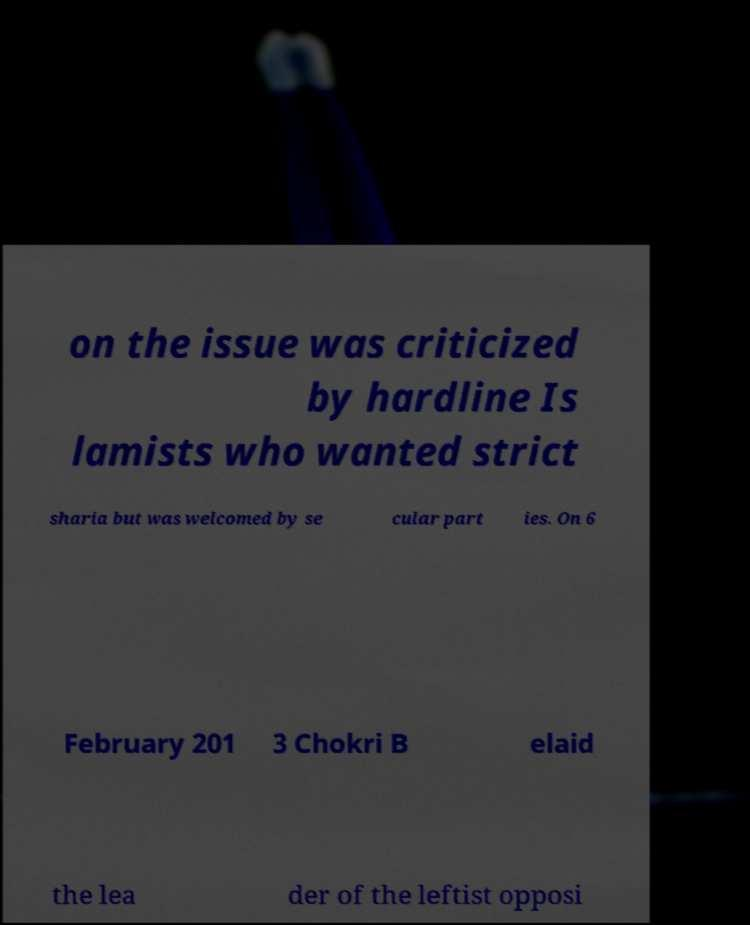There's text embedded in this image that I need extracted. Can you transcribe it verbatim? on the issue was criticized by hardline Is lamists who wanted strict sharia but was welcomed by se cular part ies. On 6 February 201 3 Chokri B elaid the lea der of the leftist opposi 